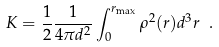<formula> <loc_0><loc_0><loc_500><loc_500>K = \frac { 1 } { 2 } \frac { 1 } { 4 { \pi } d ^ { 2 } } \int _ { 0 } ^ { r _ { \max } } \rho ^ { 2 } ( r ) d ^ { 3 } r \ .</formula> 